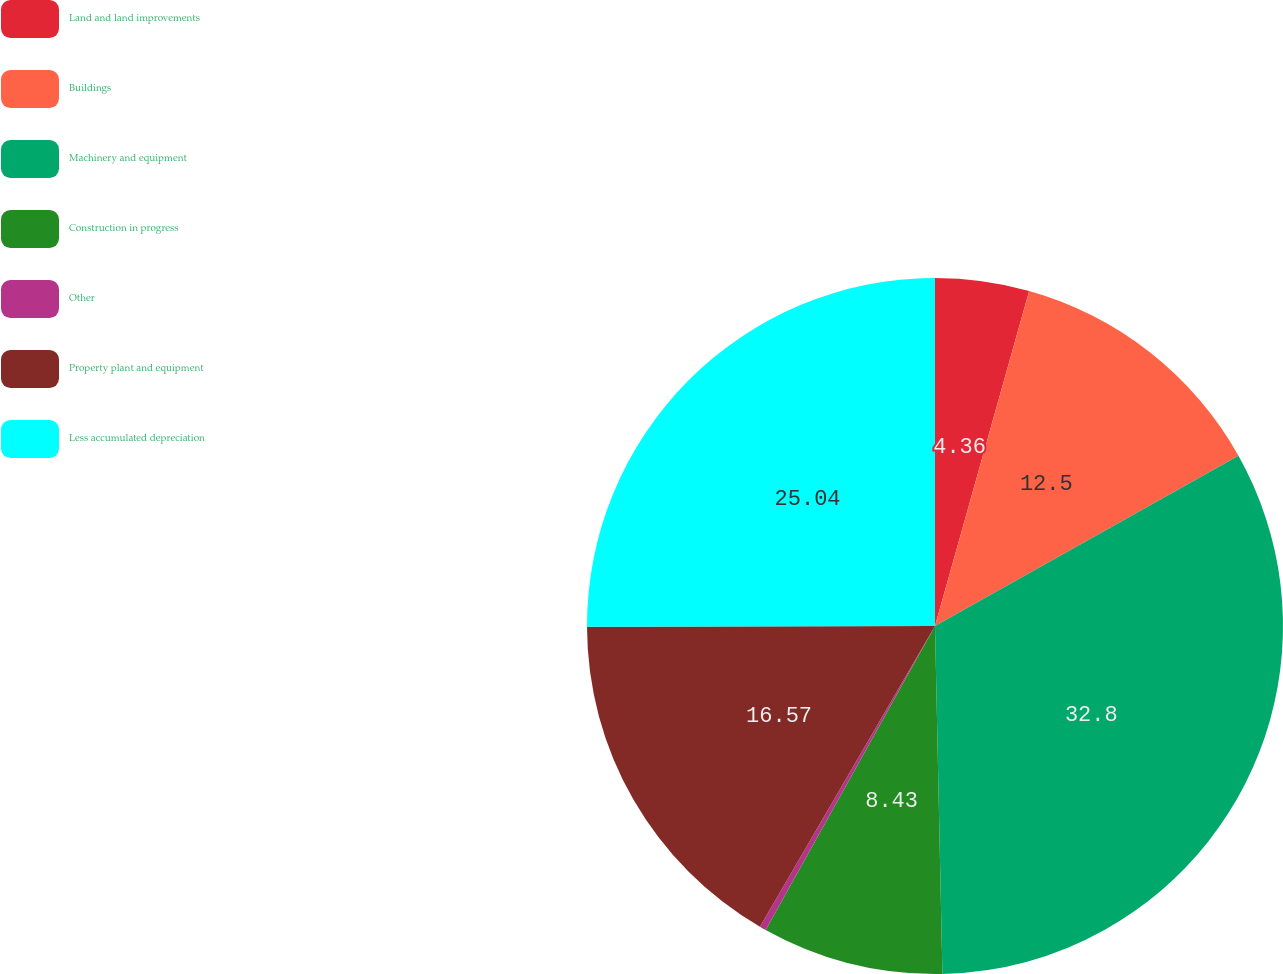Convert chart. <chart><loc_0><loc_0><loc_500><loc_500><pie_chart><fcel>Land and land improvements<fcel>Buildings<fcel>Machinery and equipment<fcel>Construction in progress<fcel>Other<fcel>Property plant and equipment<fcel>Less accumulated depreciation<nl><fcel>4.36%<fcel>12.5%<fcel>32.8%<fcel>8.43%<fcel>0.3%<fcel>16.57%<fcel>25.04%<nl></chart> 